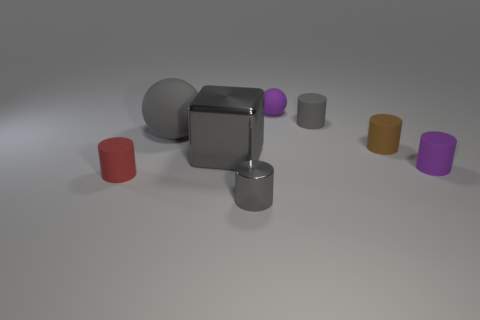Subtract all small gray shiny cylinders. How many cylinders are left? 4 Subtract 1 cylinders. How many cylinders are left? 4 Subtract all brown cylinders. How many cylinders are left? 4 Add 1 metallic objects. How many objects exist? 9 Subtract all green cylinders. Subtract all cyan cubes. How many cylinders are left? 5 Subtract all blocks. How many objects are left? 7 Subtract 0 yellow cylinders. How many objects are left? 8 Subtract all yellow rubber cylinders. Subtract all large balls. How many objects are left? 7 Add 8 tiny purple spheres. How many tiny purple spheres are left? 9 Add 4 purple balls. How many purple balls exist? 5 